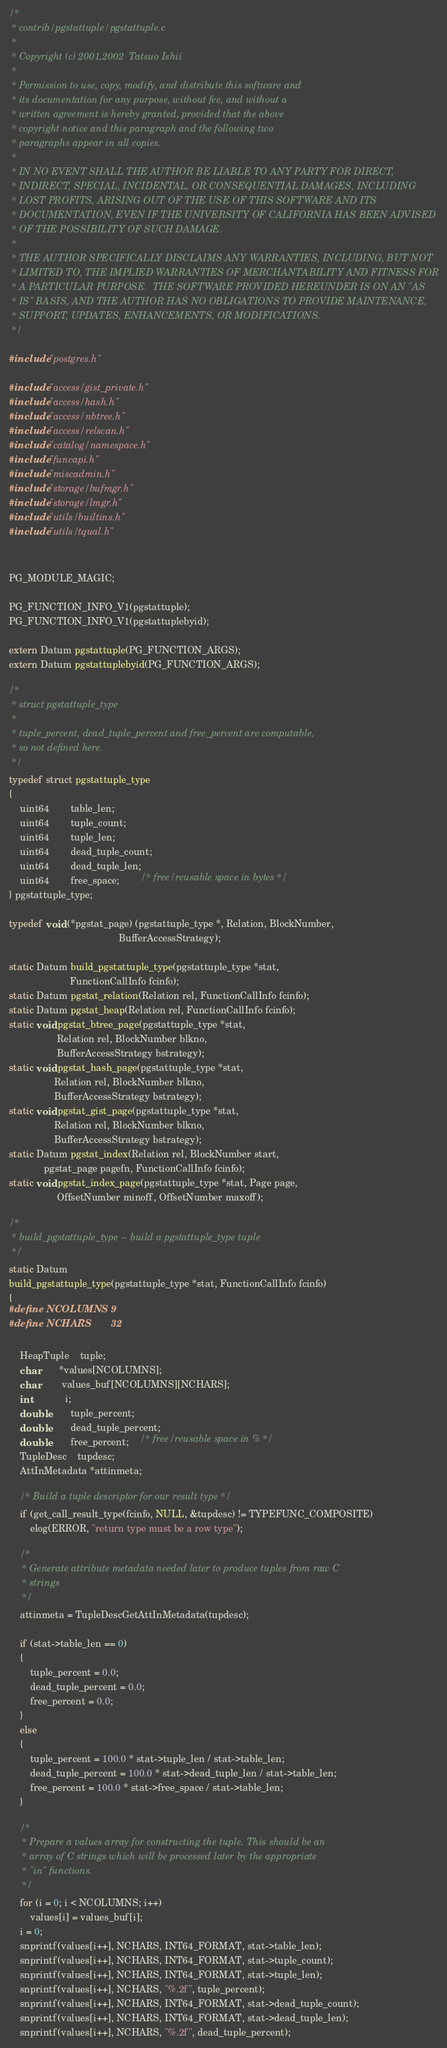Convert code to text. <code><loc_0><loc_0><loc_500><loc_500><_C_>/*
 * contrib/pgstattuple/pgstattuple.c
 *
 * Copyright (c) 2001,2002	Tatsuo Ishii
 *
 * Permission to use, copy, modify, and distribute this software and
 * its documentation for any purpose, without fee, and without a
 * written agreement is hereby granted, provided that the above
 * copyright notice and this paragraph and the following two
 * paragraphs appear in all copies.
 *
 * IN NO EVENT SHALL THE AUTHOR BE LIABLE TO ANY PARTY FOR DIRECT,
 * INDIRECT, SPECIAL, INCIDENTAL, OR CONSEQUENTIAL DAMAGES, INCLUDING
 * LOST PROFITS, ARISING OUT OF THE USE OF THIS SOFTWARE AND ITS
 * DOCUMENTATION, EVEN IF THE UNIVERSITY OF CALIFORNIA HAS BEEN ADVISED
 * OF THE POSSIBILITY OF SUCH DAMAGE.
 *
 * THE AUTHOR SPECIFICALLY DISCLAIMS ANY WARRANTIES, INCLUDING, BUT NOT
 * LIMITED TO, THE IMPLIED WARRANTIES OF MERCHANTABILITY AND FITNESS FOR
 * A PARTICULAR PURPOSE.  THE SOFTWARE PROVIDED HEREUNDER IS ON AN "AS
 * IS" BASIS, AND THE AUTHOR HAS NO OBLIGATIONS TO PROVIDE MAINTENANCE,
 * SUPPORT, UPDATES, ENHANCEMENTS, OR MODIFICATIONS.
 */

#include "postgres.h"

#include "access/gist_private.h"
#include "access/hash.h"
#include "access/nbtree.h"
#include "access/relscan.h"
#include "catalog/namespace.h"
#include "funcapi.h"
#include "miscadmin.h"
#include "storage/bufmgr.h"
#include "storage/lmgr.h"
#include "utils/builtins.h"
#include "utils/tqual.h"


PG_MODULE_MAGIC;

PG_FUNCTION_INFO_V1(pgstattuple);
PG_FUNCTION_INFO_V1(pgstattuplebyid);

extern Datum pgstattuple(PG_FUNCTION_ARGS);
extern Datum pgstattuplebyid(PG_FUNCTION_ARGS);

/*
 * struct pgstattuple_type
 *
 * tuple_percent, dead_tuple_percent and free_percent are computable,
 * so not defined here.
 */
typedef struct pgstattuple_type
{
	uint64		table_len;
	uint64		tuple_count;
	uint64		tuple_len;
	uint64		dead_tuple_count;
	uint64		dead_tuple_len;
	uint64		free_space;		/* free/reusable space in bytes */
} pgstattuple_type;

typedef void (*pgstat_page) (pgstattuple_type *, Relation, BlockNumber,
										 BufferAccessStrategy);

static Datum build_pgstattuple_type(pgstattuple_type *stat,
					   FunctionCallInfo fcinfo);
static Datum pgstat_relation(Relation rel, FunctionCallInfo fcinfo);
static Datum pgstat_heap(Relation rel, FunctionCallInfo fcinfo);
static void pgstat_btree_page(pgstattuple_type *stat,
				  Relation rel, BlockNumber blkno,
				  BufferAccessStrategy bstrategy);
static void pgstat_hash_page(pgstattuple_type *stat,
				 Relation rel, BlockNumber blkno,
				 BufferAccessStrategy bstrategy);
static void pgstat_gist_page(pgstattuple_type *stat,
				 Relation rel, BlockNumber blkno,
				 BufferAccessStrategy bstrategy);
static Datum pgstat_index(Relation rel, BlockNumber start,
			 pgstat_page pagefn, FunctionCallInfo fcinfo);
static void pgstat_index_page(pgstattuple_type *stat, Page page,
				  OffsetNumber minoff, OffsetNumber maxoff);

/*
 * build_pgstattuple_type -- build a pgstattuple_type tuple
 */
static Datum
build_pgstattuple_type(pgstattuple_type *stat, FunctionCallInfo fcinfo)
{
#define NCOLUMNS	9
#define NCHARS		32

	HeapTuple	tuple;
	char	   *values[NCOLUMNS];
	char		values_buf[NCOLUMNS][NCHARS];
	int			i;
	double		tuple_percent;
	double		dead_tuple_percent;
	double		free_percent;	/* free/reusable space in % */
	TupleDesc	tupdesc;
	AttInMetadata *attinmeta;

	/* Build a tuple descriptor for our result type */
	if (get_call_result_type(fcinfo, NULL, &tupdesc) != TYPEFUNC_COMPOSITE)
		elog(ERROR, "return type must be a row type");

	/*
	 * Generate attribute metadata needed later to produce tuples from raw C
	 * strings
	 */
	attinmeta = TupleDescGetAttInMetadata(tupdesc);

	if (stat->table_len == 0)
	{
		tuple_percent = 0.0;
		dead_tuple_percent = 0.0;
		free_percent = 0.0;
	}
	else
	{
		tuple_percent = 100.0 * stat->tuple_len / stat->table_len;
		dead_tuple_percent = 100.0 * stat->dead_tuple_len / stat->table_len;
		free_percent = 100.0 * stat->free_space / stat->table_len;
	}

	/*
	 * Prepare a values array for constructing the tuple. This should be an
	 * array of C strings which will be processed later by the appropriate
	 * "in" functions.
	 */
	for (i = 0; i < NCOLUMNS; i++)
		values[i] = values_buf[i];
	i = 0;
	snprintf(values[i++], NCHARS, INT64_FORMAT, stat->table_len);
	snprintf(values[i++], NCHARS, INT64_FORMAT, stat->tuple_count);
	snprintf(values[i++], NCHARS, INT64_FORMAT, stat->tuple_len);
	snprintf(values[i++], NCHARS, "%.2f", tuple_percent);
	snprintf(values[i++], NCHARS, INT64_FORMAT, stat->dead_tuple_count);
	snprintf(values[i++], NCHARS, INT64_FORMAT, stat->dead_tuple_len);
	snprintf(values[i++], NCHARS, "%.2f", dead_tuple_percent);</code> 